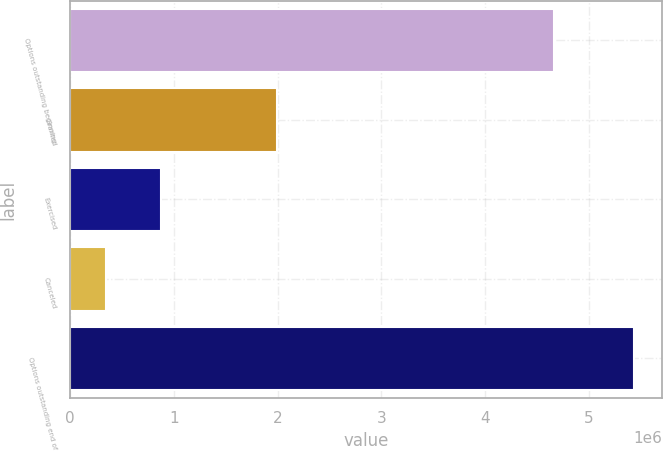<chart> <loc_0><loc_0><loc_500><loc_500><bar_chart><fcel>Options outstanding beginning<fcel>Granted<fcel>Exercised<fcel>Canceled<fcel>Options outstanding end of<nl><fcel>4.66542e+06<fcel>1.99258e+06<fcel>877786<fcel>342154<fcel>5.43806e+06<nl></chart> 